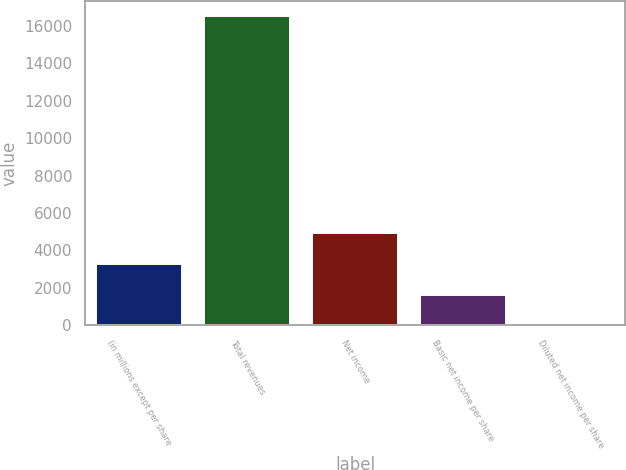Convert chart to OTSL. <chart><loc_0><loc_0><loc_500><loc_500><bar_chart><fcel>(in millions except per share<fcel>Total revenues<fcel>Net income<fcel>Basic net income per share<fcel>Diluted net income per share<nl><fcel>3297.44<fcel>16485<fcel>4945.89<fcel>1648.99<fcel>0.54<nl></chart> 